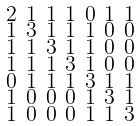<formula> <loc_0><loc_0><loc_500><loc_500>\begin{smallmatrix} 2 & 1 & 1 & 1 & 0 & 1 & 1 \\ 1 & 3 & 1 & 1 & 1 & 0 & 0 \\ 1 & 1 & 3 & 1 & 1 & 0 & 0 \\ 1 & 1 & 1 & 3 & 1 & 0 & 0 \\ 0 & 1 & 1 & 1 & 3 & 1 & 1 \\ 1 & 0 & 0 & 0 & 1 & 3 & 1 \\ 1 & 0 & 0 & 0 & 1 & 1 & 3 \end{smallmatrix}</formula> 